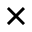<formula> <loc_0><loc_0><loc_500><loc_500>\times</formula> 